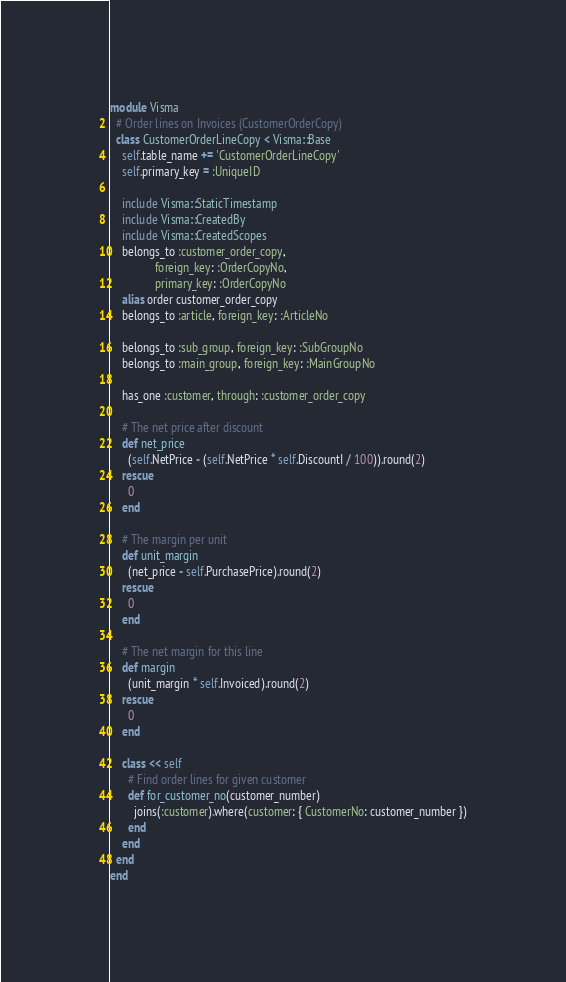Convert code to text. <code><loc_0><loc_0><loc_500><loc_500><_Ruby_>module Visma
  # Order lines on Invoices (CustomerOrderCopy)
  class CustomerOrderLineCopy < Visma::Base
    self.table_name += 'CustomerOrderLineCopy'
    self.primary_key = :UniqueID

    include Visma::StaticTimestamp
    include Visma::CreatedBy
    include Visma::CreatedScopes
    belongs_to :customer_order_copy,
               foreign_key: :OrderCopyNo,
               primary_key: :OrderCopyNo
    alias order customer_order_copy
    belongs_to :article, foreign_key: :ArticleNo

    belongs_to :sub_group, foreign_key: :SubGroupNo
    belongs_to :main_group, foreign_key: :MainGroupNo

    has_one :customer, through: :customer_order_copy

    # The net price after discount
    def net_price
      (self.NetPrice - (self.NetPrice * self.DiscountI / 100)).round(2)
    rescue
      0
    end

    # The margin per unit
    def unit_margin
      (net_price - self.PurchasePrice).round(2)
    rescue
      0
    end

    # The net margin for this line
    def margin
      (unit_margin * self.Invoiced).round(2)
    rescue
      0
    end

    class << self
      # Find order lines for given customer
      def for_customer_no(customer_number)
        joins(:customer).where(customer: { CustomerNo: customer_number })
      end
    end
  end
end
</code> 